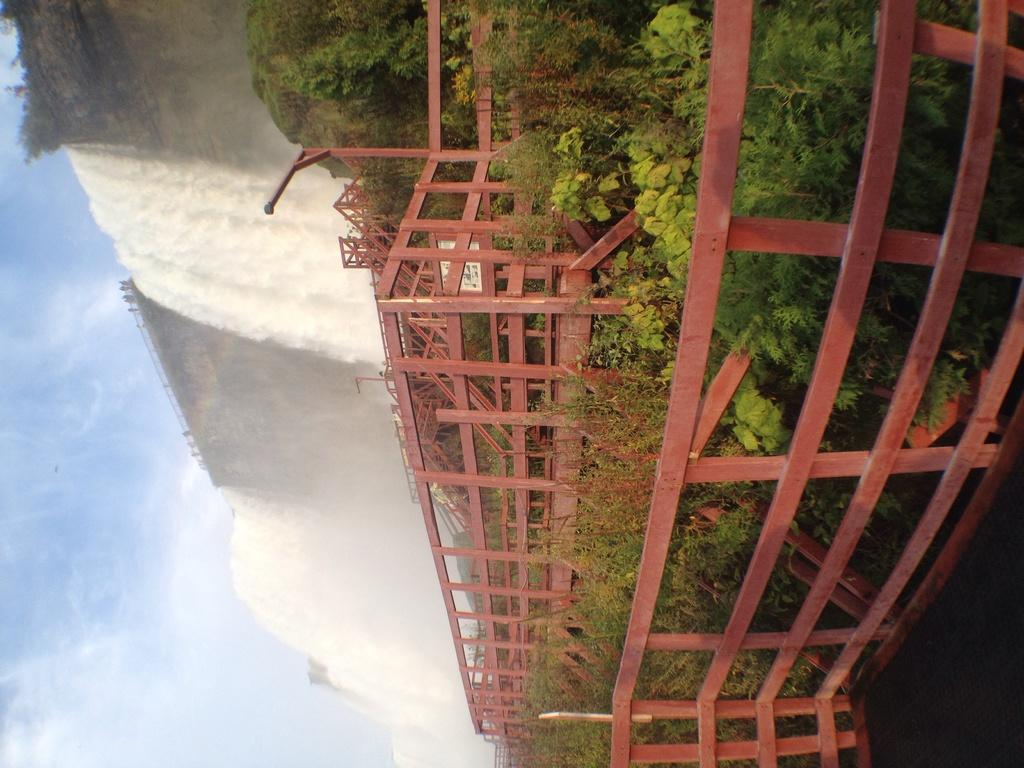What type of structure can be seen in the image? There is fencing in the image. What else is present in the image besides the fencing? There are plants in the image. What can be seen in the background of the image? There is a waterfall and the sky visible in the background of the image. What type of toy is being used to control the waterfall in the image? There is no toy present in the image, and the waterfall is not being controlled by any object. What emotion might the plants be feeling in the image? Plants do not have emotions, so it is not possible to determine how they might be feeling. 